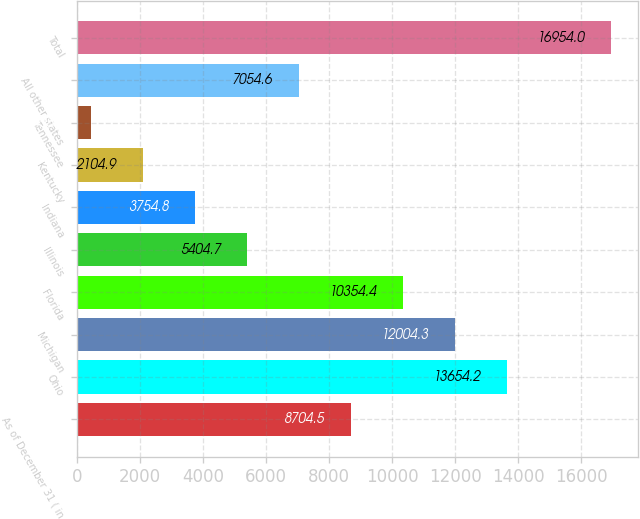<chart> <loc_0><loc_0><loc_500><loc_500><bar_chart><fcel>As of December 31 ( in<fcel>Ohio<fcel>Michigan<fcel>Florida<fcel>Illinois<fcel>Indiana<fcel>Kentucky<fcel>Tennessee<fcel>All other states<fcel>Total<nl><fcel>8704.5<fcel>13654.2<fcel>12004.3<fcel>10354.4<fcel>5404.7<fcel>3754.8<fcel>2104.9<fcel>455<fcel>7054.6<fcel>16954<nl></chart> 